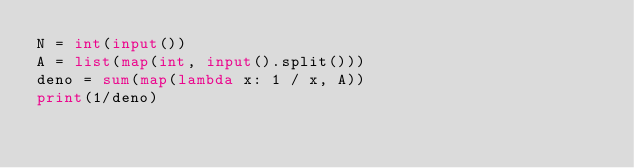<code> <loc_0><loc_0><loc_500><loc_500><_Python_>N = int(input())
A = list(map(int, input().split()))
deno = sum(map(lambda x: 1 / x, A))
print(1/deno)
</code> 